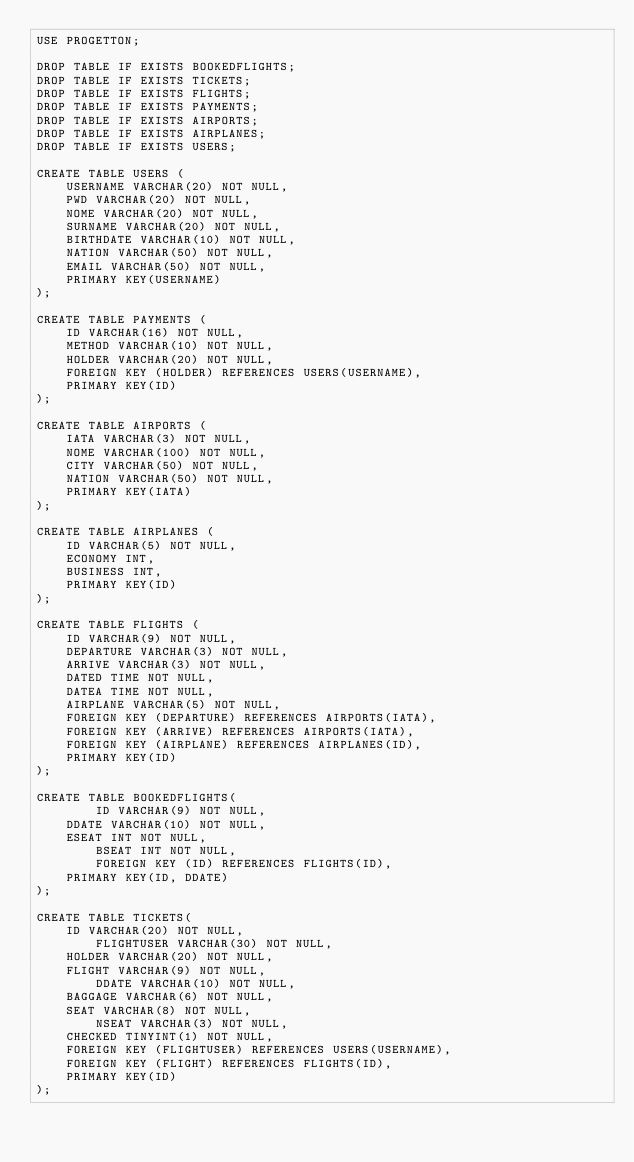Convert code to text. <code><loc_0><loc_0><loc_500><loc_500><_SQL_>USE PROGETTON;

DROP TABLE IF EXISTS BOOKEDFLIGHTS;
DROP TABLE IF EXISTS TICKETS;
DROP TABLE IF EXISTS FLIGHTS;
DROP TABLE IF EXISTS PAYMENTS;
DROP TABLE IF EXISTS AIRPORTS;
DROP TABLE IF EXISTS AIRPLANES;
DROP TABLE IF EXISTS USERS;

CREATE TABLE USERS (
		USERNAME VARCHAR(20) NOT NULL,
		PWD VARCHAR(20) NOT NULL,
		NOME VARCHAR(20) NOT NULL,
		SURNAME VARCHAR(20) NOT NULL,
		BIRTHDATE VARCHAR(10) NOT NULL,
		NATION VARCHAR(50) NOT NULL,
		EMAIL VARCHAR(50) NOT NULL,
		PRIMARY KEY(USERNAME)
);

CREATE TABLE PAYMENTS (
		ID VARCHAR(16) NOT NULL,
		METHOD VARCHAR(10) NOT NULL,
		HOLDER VARCHAR(20) NOT NULL,
		FOREIGN KEY (HOLDER) REFERENCES USERS(USERNAME),
		PRIMARY KEY(ID)
);

CREATE TABLE AIRPORTS (
		IATA VARCHAR(3) NOT NULL,
		NOME VARCHAR(100) NOT NULL,
		CITY VARCHAR(50) NOT NULL,
		NATION VARCHAR(50) NOT NULL,
		PRIMARY KEY(IATA)
);

CREATE TABLE AIRPLANES (
		ID VARCHAR(5) NOT NULL,
		ECONOMY INT,
		BUSINESS INT,
		PRIMARY KEY(ID)
);

CREATE TABLE FLIGHTS (
		ID VARCHAR(9) NOT NULL,
		DEPARTURE VARCHAR(3) NOT NULL,
		ARRIVE VARCHAR(3) NOT NULL,
		DATED TIME NOT NULL,
		DATEA TIME NOT NULL,
		AIRPLANE VARCHAR(5) NOT NULL,
		FOREIGN KEY (DEPARTURE) REFERENCES AIRPORTS(IATA),
		FOREIGN KEY (ARRIVE) REFERENCES AIRPORTS(IATA),
		FOREIGN KEY (AIRPLANE) REFERENCES AIRPLANES(ID),
		PRIMARY KEY(ID)
);

CREATE TABLE BOOKEDFLIGHTS(
        ID VARCHAR(9) NOT NULL,
		DDATE VARCHAR(10) NOT NULL,
		ESEAT INT NOT NULL,
        BSEAT INT NOT NULL,
        FOREIGN KEY (ID) REFERENCES FLIGHTS(ID),
		PRIMARY KEY(ID, DDATE)
);

CREATE TABLE TICKETS(
		ID VARCHAR(20) NOT NULL,
        FLIGHTUSER VARCHAR(30) NOT NULL,
		HOLDER VARCHAR(20) NOT NULL,
		FLIGHT VARCHAR(9) NOT NULL,
        DDATE VARCHAR(10) NOT NULL,
		BAGGAGE VARCHAR(6) NOT NULL,
		SEAT VARCHAR(8) NOT NULL,
        NSEAT VARCHAR(3) NOT NULL,
		CHECKED TINYINT(1) NOT NULL,
		FOREIGN KEY (FLIGHTUSER) REFERENCES USERS(USERNAME),
		FOREIGN KEY (FLIGHT) REFERENCES FLIGHTS(ID),
		PRIMARY KEY(ID)
);

</code> 